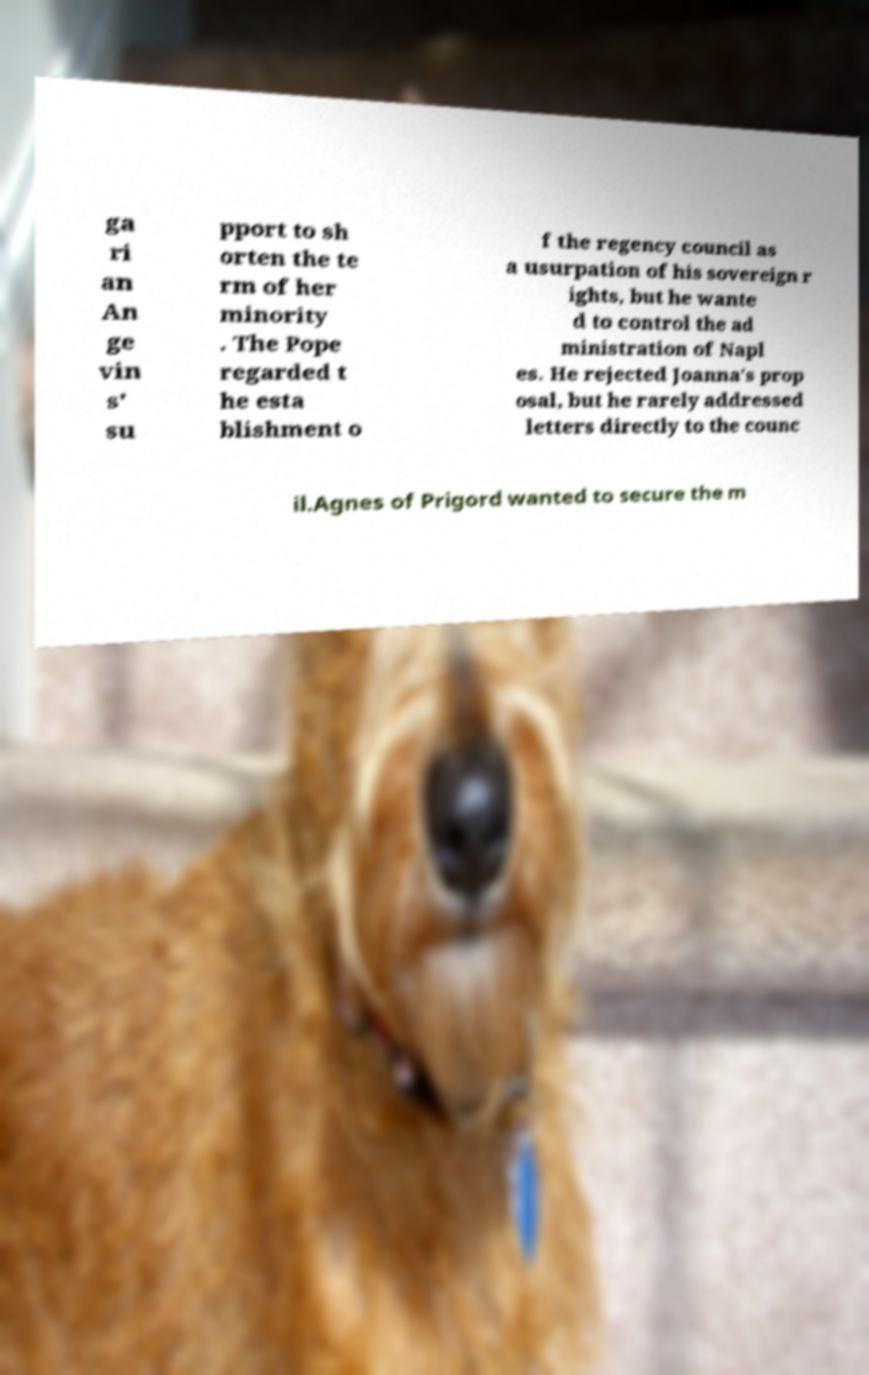Please read and relay the text visible in this image. What does it say? ga ri an An ge vin s' su pport to sh orten the te rm of her minority . The Pope regarded t he esta blishment o f the regency council as a usurpation of his sovereign r ights, but he wante d to control the ad ministration of Napl es. He rejected Joanna's prop osal, but he rarely addressed letters directly to the counc il.Agnes of Prigord wanted to secure the m 